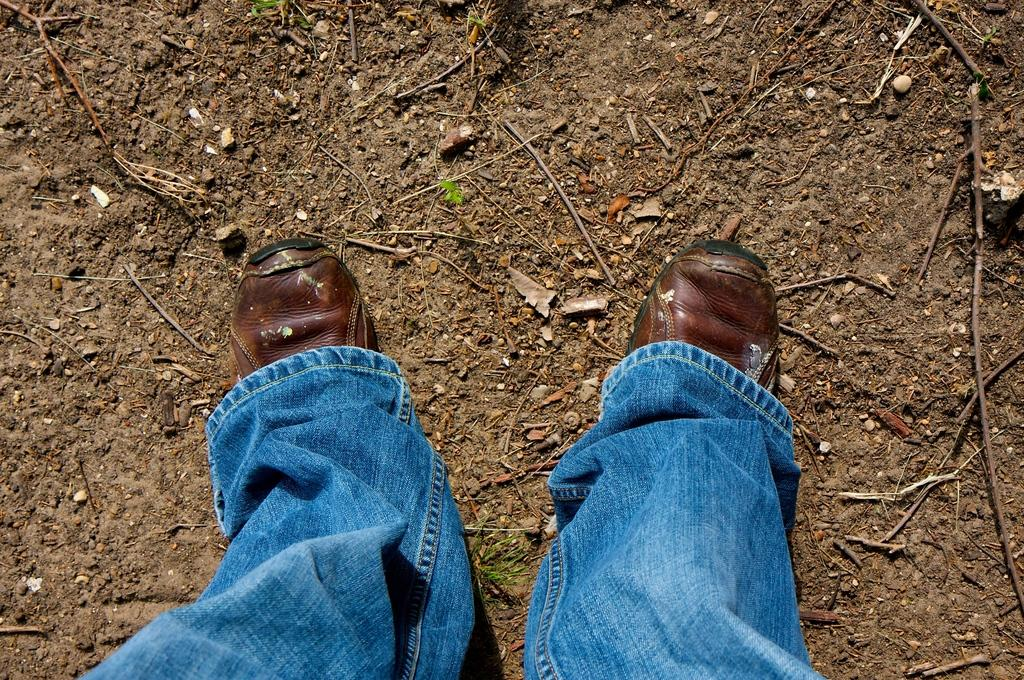What part of a person can be seen in the image? There are a person's legs visible in the image. What type of clothing is the person wearing on their legs? The person is wearing jeans. What type of footwear is the person wearing? The person is wearing shoes. Can you describe the person's posture in the image? The person appears to be standing. What can be seen on the ground in the image? There are many sticks on the ground in the image. What type of bottle is the person holding in the image? There is no bottle visible in the image; only the person's legs, jeans, shoes, and the sticks on the ground can be seen. 